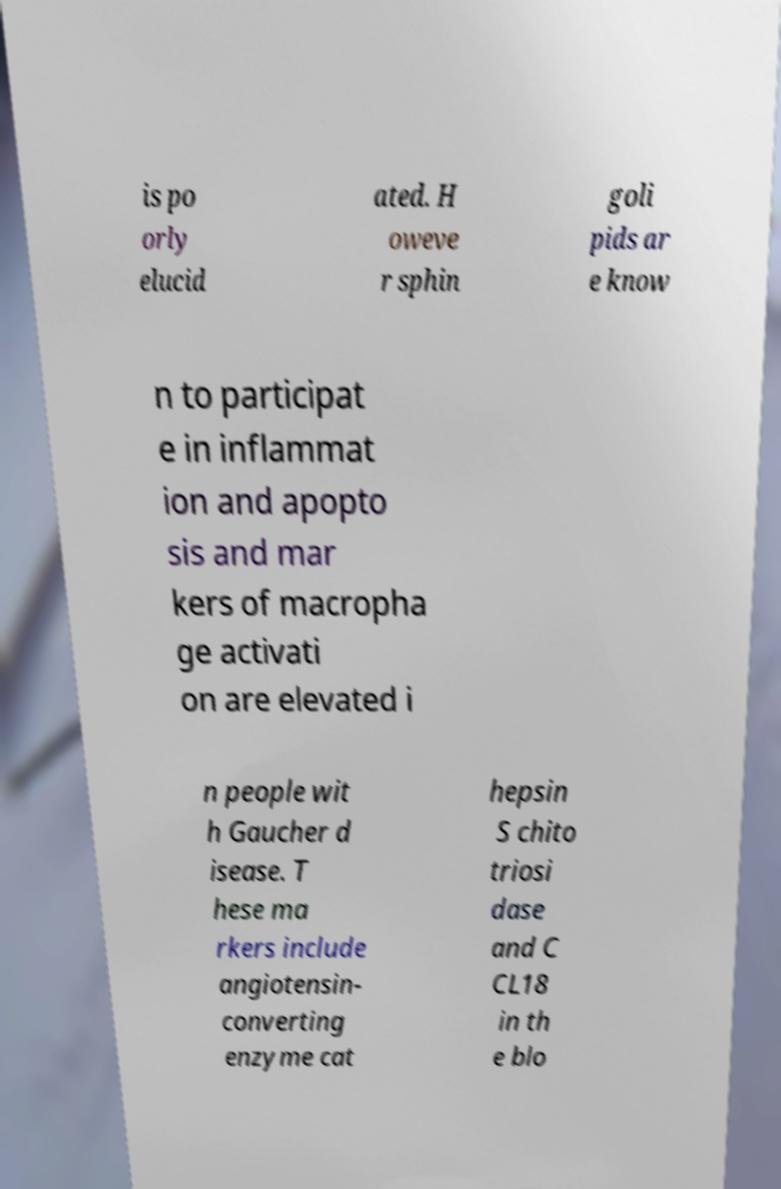Could you assist in decoding the text presented in this image and type it out clearly? is po orly elucid ated. H oweve r sphin goli pids ar e know n to participat e in inflammat ion and apopto sis and mar kers of macropha ge activati on are elevated i n people wit h Gaucher d isease. T hese ma rkers include angiotensin- converting enzyme cat hepsin S chito triosi dase and C CL18 in th e blo 